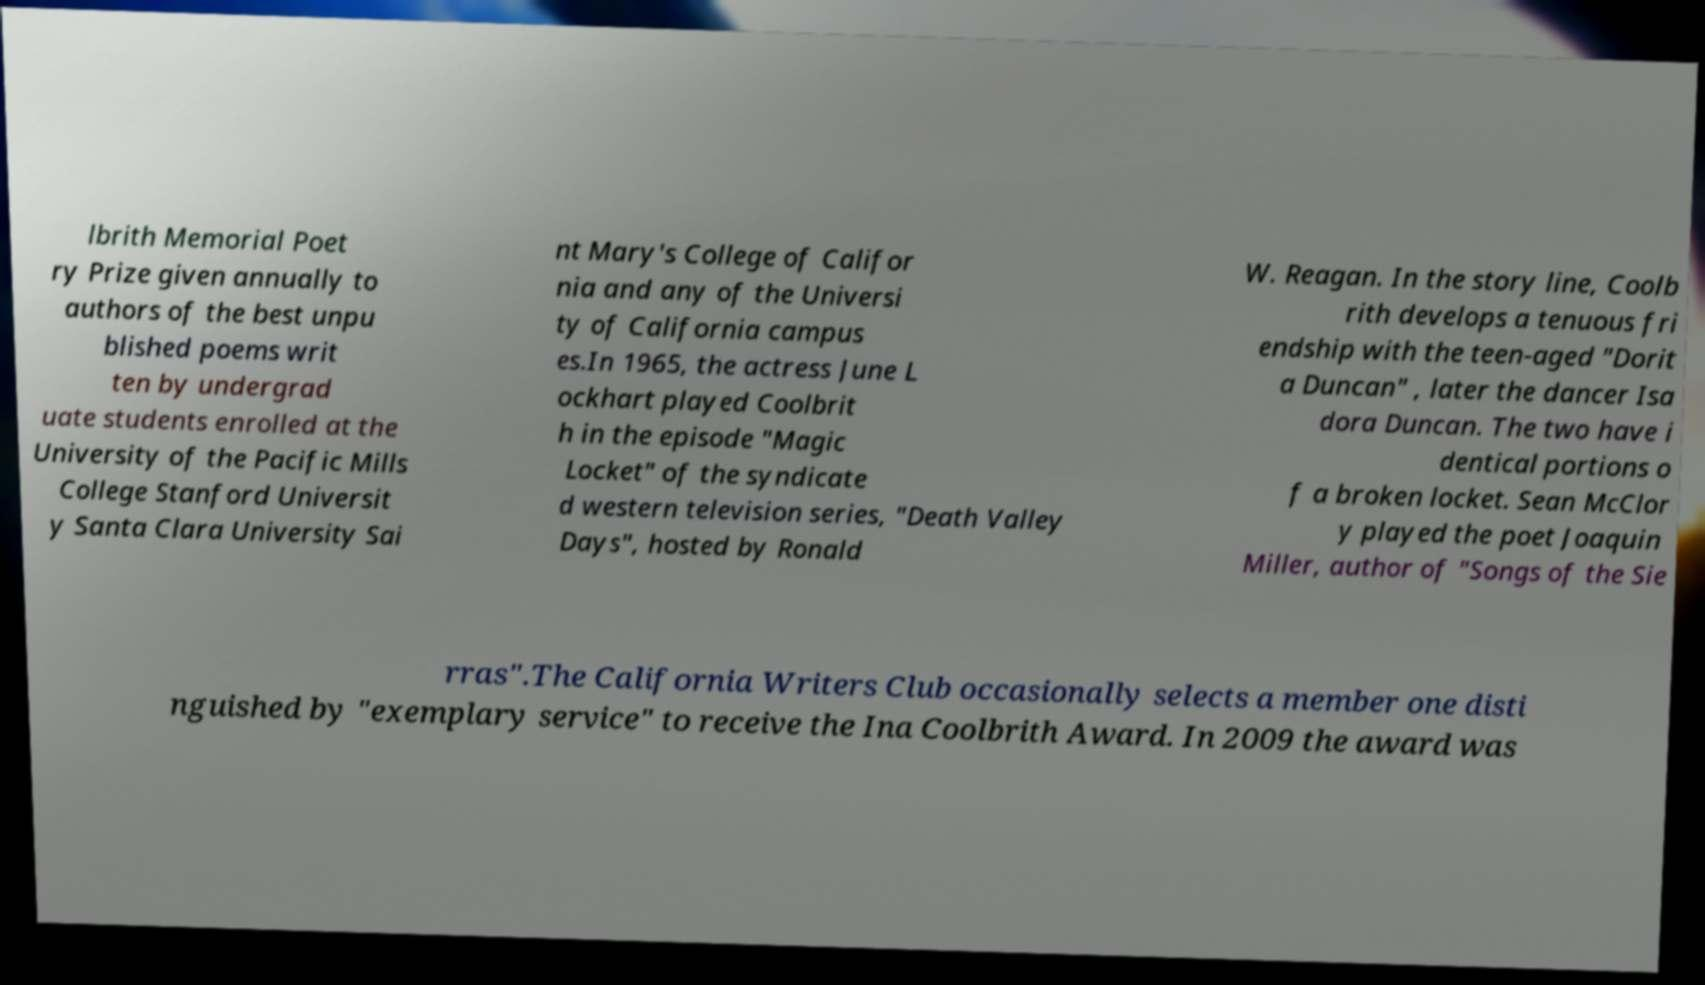What messages or text are displayed in this image? I need them in a readable, typed format. lbrith Memorial Poet ry Prize given annually to authors of the best unpu blished poems writ ten by undergrad uate students enrolled at the University of the Pacific Mills College Stanford Universit y Santa Clara University Sai nt Mary's College of Califor nia and any of the Universi ty of California campus es.In 1965, the actress June L ockhart played Coolbrit h in the episode "Magic Locket" of the syndicate d western television series, "Death Valley Days", hosted by Ronald W. Reagan. In the story line, Coolb rith develops a tenuous fri endship with the teen-aged "Dorit a Duncan" , later the dancer Isa dora Duncan. The two have i dentical portions o f a broken locket. Sean McClor y played the poet Joaquin Miller, author of "Songs of the Sie rras".The California Writers Club occasionally selects a member one disti nguished by "exemplary service" to receive the Ina Coolbrith Award. In 2009 the award was 